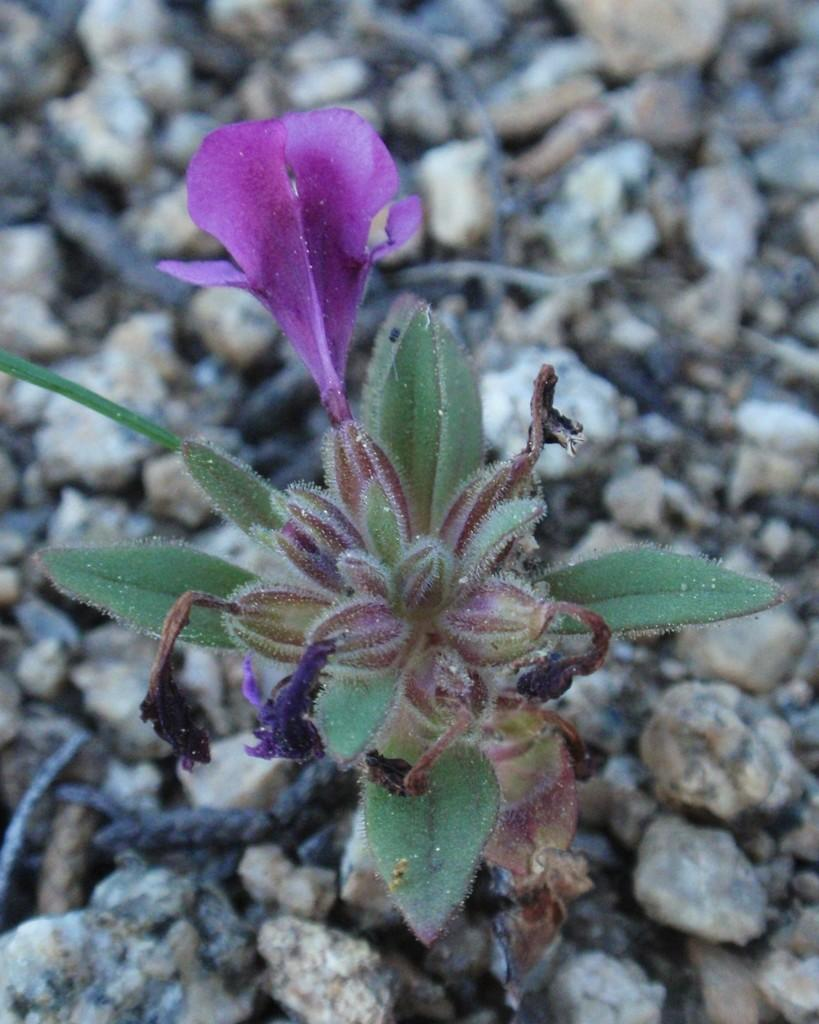What type of living organism can be seen in the image? There is a plant in the image. What specific part of the plant is visible? There is a flower in the image. What type of inanimate objects are present in the image? There are stones in the image. What month is it in the image? The month is not mentioned or depicted in the image, so it cannot be determined. 